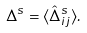Convert formula to latex. <formula><loc_0><loc_0><loc_500><loc_500>\Delta ^ { s } = \langle \hat { \Delta } ^ { s } _ { i j } \rangle .</formula> 